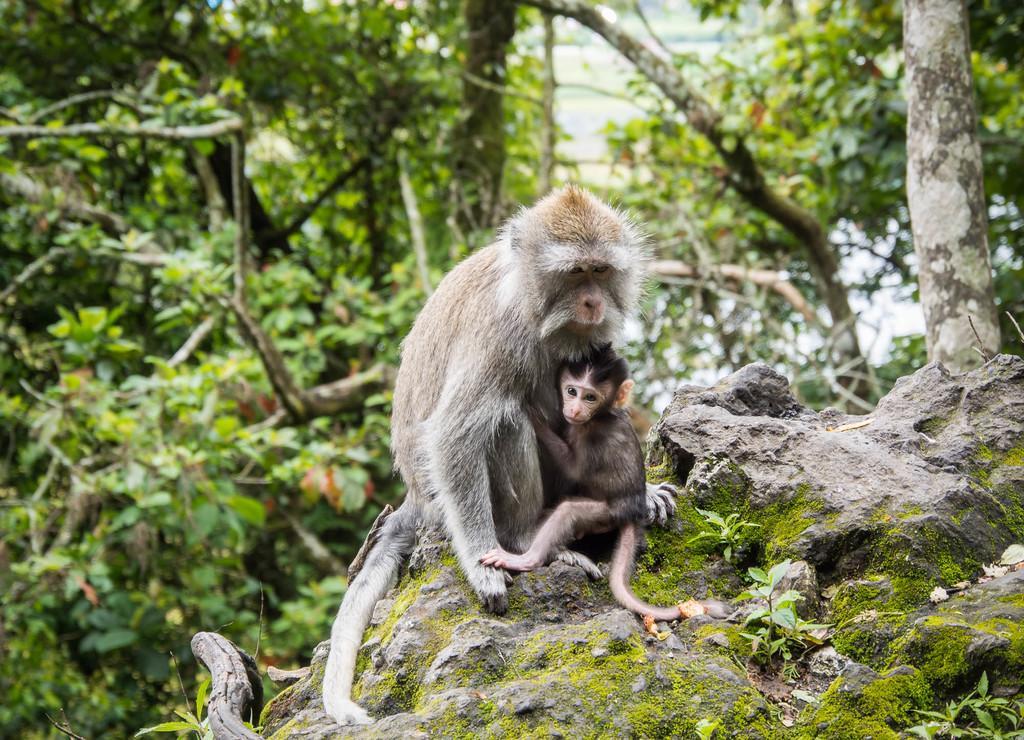In one or two sentences, can you explain what this image depicts? In this picture we can see two monkeys here, in the background there are some trees. 